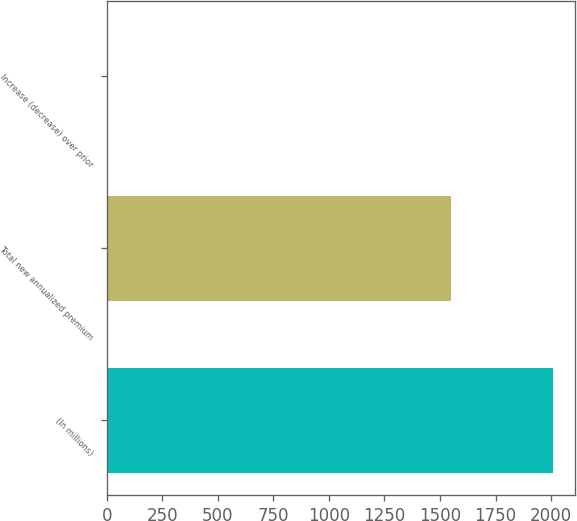<chart> <loc_0><loc_0><loc_500><loc_500><bar_chart><fcel>(In millions)<fcel>Total new annualized premium<fcel>Increase (decrease) over prior<nl><fcel>2008<fcel>1551<fcel>0.4<nl></chart> 